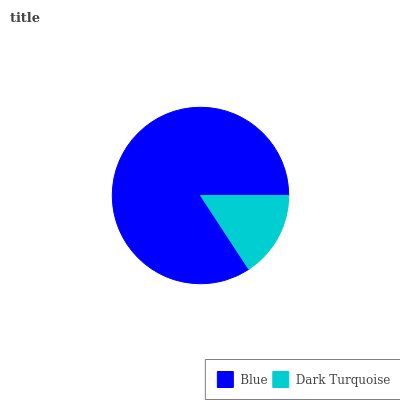Is Dark Turquoise the minimum?
Answer yes or no. Yes. Is Blue the maximum?
Answer yes or no. Yes. Is Dark Turquoise the maximum?
Answer yes or no. No. Is Blue greater than Dark Turquoise?
Answer yes or no. Yes. Is Dark Turquoise less than Blue?
Answer yes or no. Yes. Is Dark Turquoise greater than Blue?
Answer yes or no. No. Is Blue less than Dark Turquoise?
Answer yes or no. No. Is Blue the high median?
Answer yes or no. Yes. Is Dark Turquoise the low median?
Answer yes or no. Yes. Is Dark Turquoise the high median?
Answer yes or no. No. Is Blue the low median?
Answer yes or no. No. 